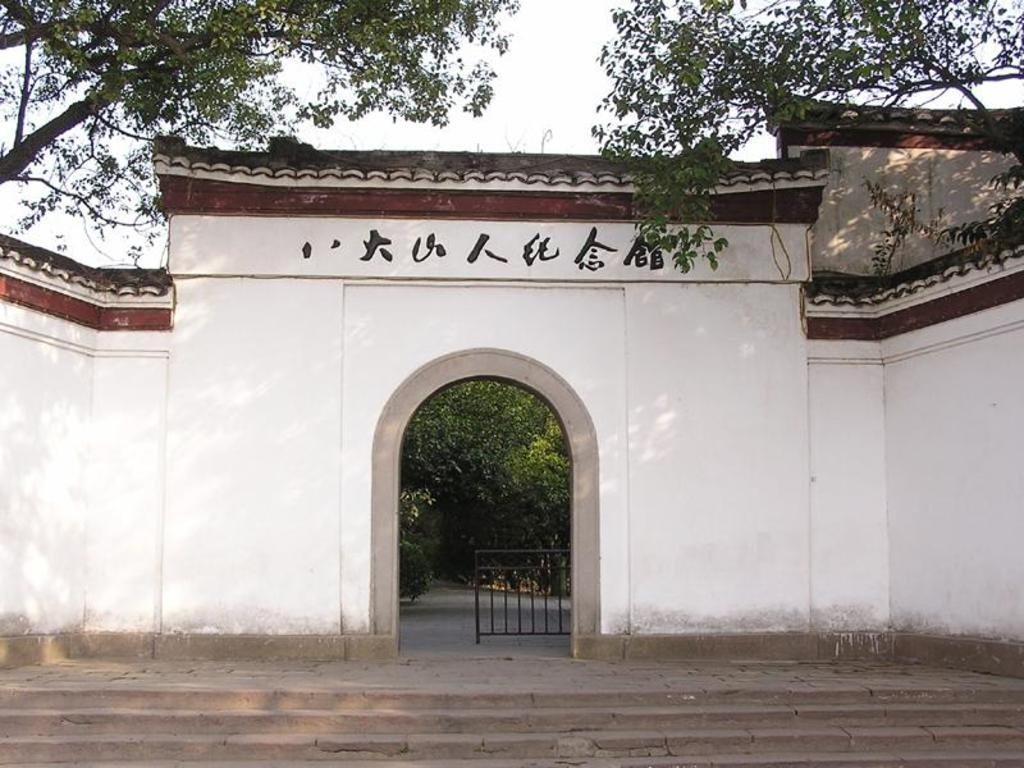What type of structure is present in the image? There are stairs in the image. What color is the wall that is visible in the image? There is a white-colored wall in the image. What type of barrier is present in the image? There is an iron gate in the image. What type of natural element is present in the image? There are trees in the image. What type of markings or symbols are visible in the image? There is text or writing visible in the image. Can you see a sign hanging from the iron gate in the image? There is no sign hanging from the iron gate in the image. Is there a scarf draped over the trees in the image? There is no scarf present in the image. 